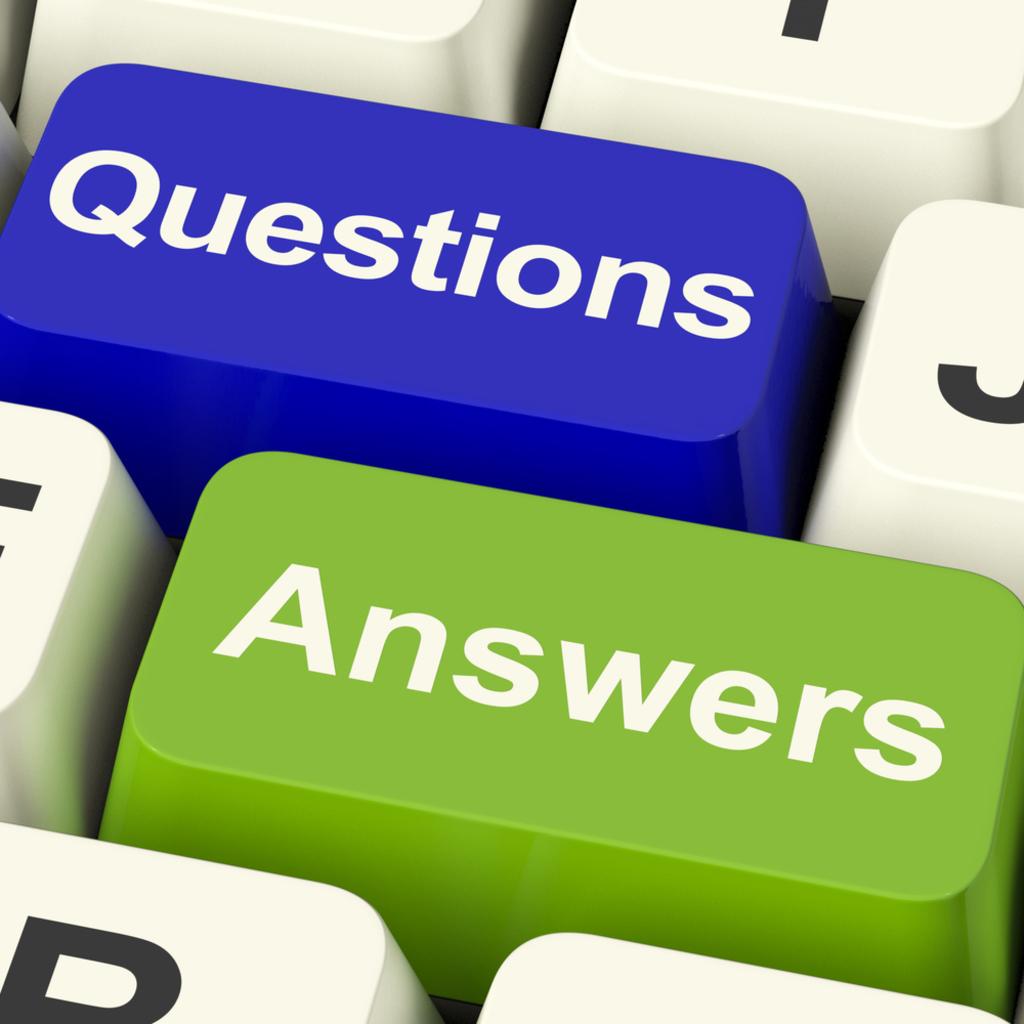Questions and what?
Make the answer very short. Answers. Answers and what?
Offer a very short reply. Questions. 